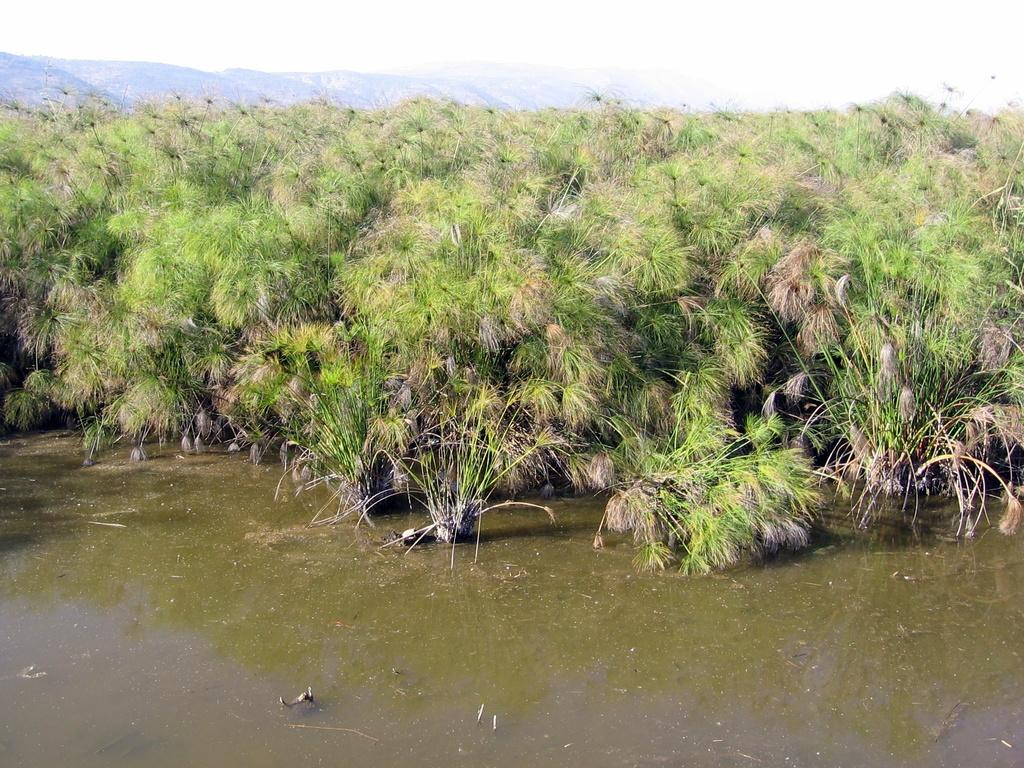What type of natural elements can be seen in the image? There are plants, mountains, and a lake visible in the image. What part of the natural environment is visible in the image? The sky is visible in the image. Can you describe the landscape in the image? The image features a landscape with plants, mountains, and a lake, with the sky visible above. What type of leather material can be seen on the band in the image? There is no band or leather material present in the image. How does the brake system work in the image? There is no brake system present in the image. 